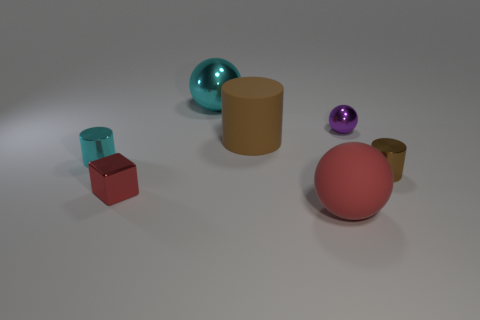Add 1 large blue metallic blocks. How many objects exist? 8 Subtract all gray blocks. How many brown cylinders are left? 2 Subtract all big matte balls. How many balls are left? 2 Subtract all cubes. How many objects are left? 6 Subtract all green balls. Subtract all green blocks. How many balls are left? 3 Subtract all large cylinders. Subtract all small purple metallic balls. How many objects are left? 5 Add 6 red shiny objects. How many red shiny objects are left? 7 Add 3 purple rubber cylinders. How many purple rubber cylinders exist? 3 Subtract 0 green cubes. How many objects are left? 7 